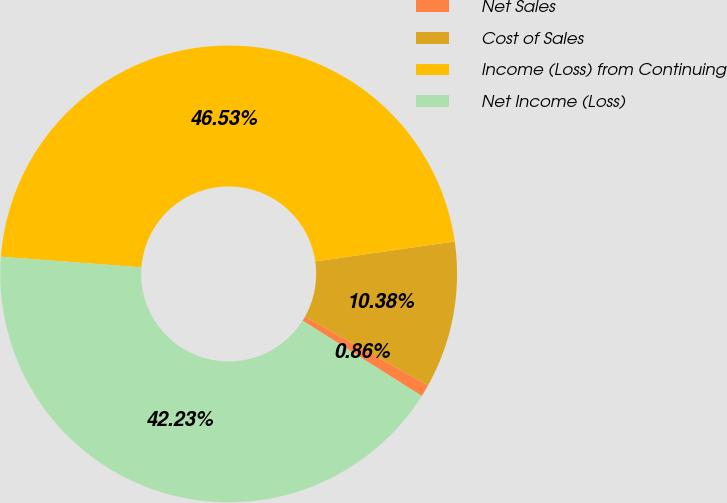Convert chart. <chart><loc_0><loc_0><loc_500><loc_500><pie_chart><fcel>Net Sales<fcel>Cost of Sales<fcel>Income (Loss) from Continuing<fcel>Net Income (Loss)<nl><fcel>0.86%<fcel>10.38%<fcel>46.53%<fcel>42.23%<nl></chart> 